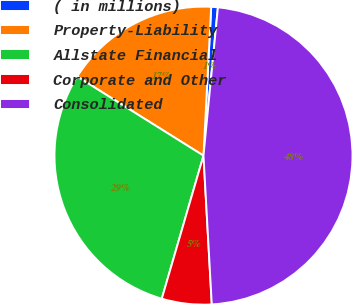Convert chart to OTSL. <chart><loc_0><loc_0><loc_500><loc_500><pie_chart><fcel>( in millions)<fcel>Property-Liability<fcel>Allstate Financial<fcel>Corporate and Other<fcel>Consolidated<nl><fcel>0.72%<fcel>16.92%<fcel>29.39%<fcel>5.4%<fcel>47.57%<nl></chart> 